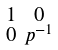<formula> <loc_0><loc_0><loc_500><loc_500>\begin{smallmatrix} 1 & 0 \\ 0 & p ^ { - 1 } \end{smallmatrix}</formula> 